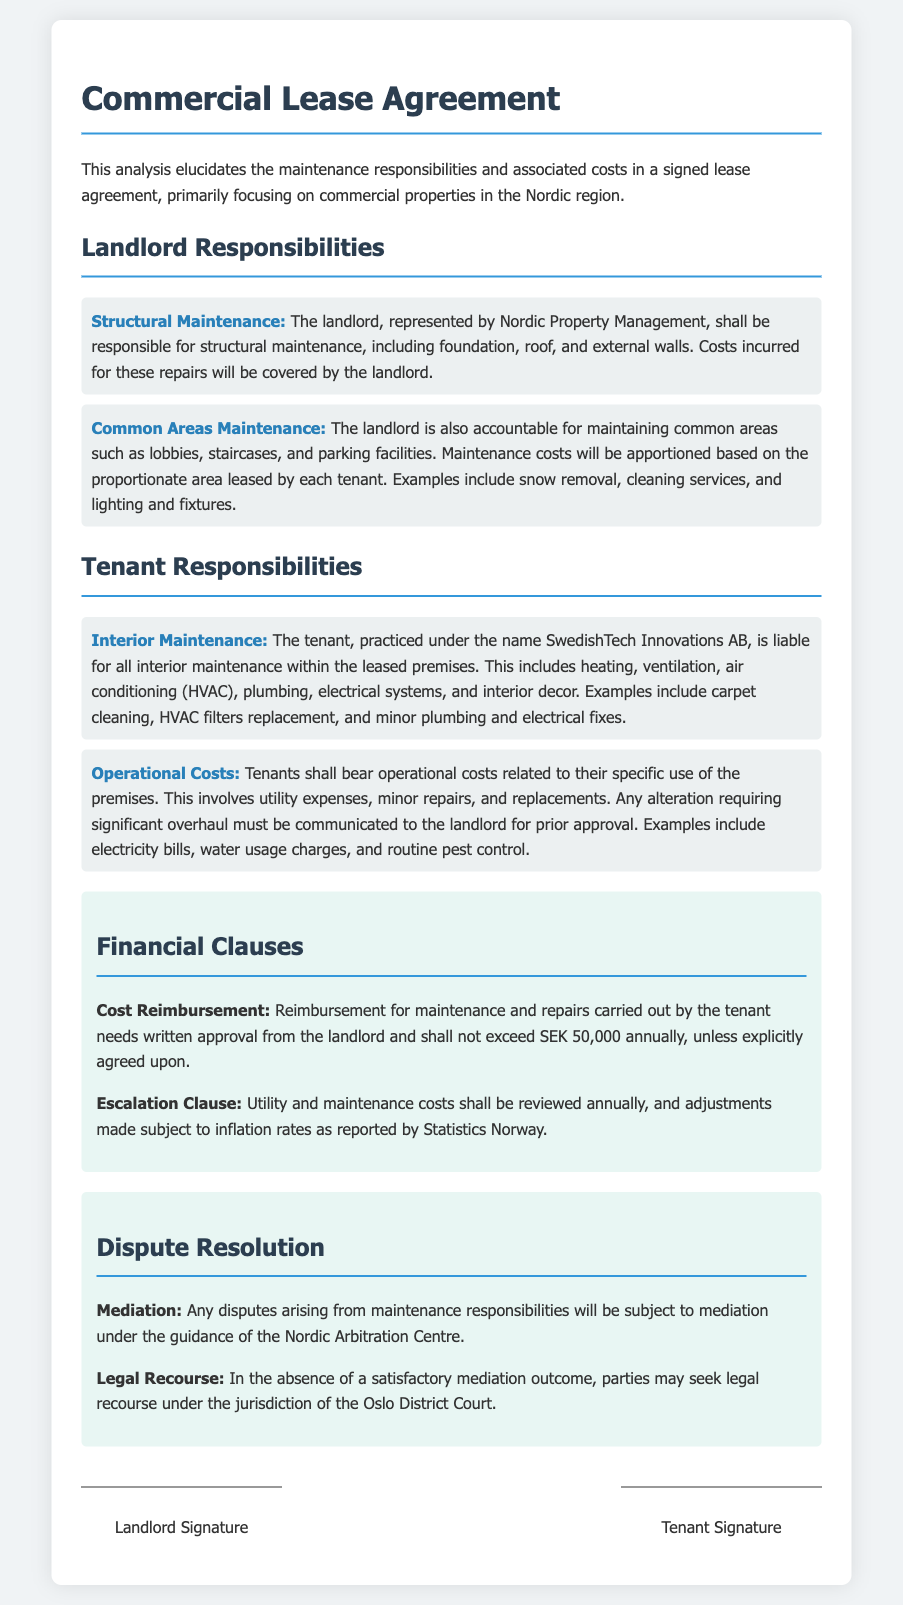what are the landlord's responsibilities? The landlord's responsibilities include structural maintenance and common areas maintenance.
Answer: structural maintenance, common areas maintenance who is the tenant in this lease agreement? The tenant in the lease agreement is identified as SwedishTech Innovations AB.
Answer: SwedishTech Innovations AB what is the annual reimbursement limit for tenant maintenance costs? The document specifies that reimbursement for maintenance does not exceed yearly SEK 50,000 without explicit agreement.
Answer: SEK 50,000 how often are utility and maintenance costs reviewed? According to the financial clauses, utility and maintenance costs are reviewed annually.
Answer: annually what type of mediation is required for disputes? The document mentions that disputes will be subject to mediation under the guidance of the Nordic Arbitration Centre.
Answer: Nordic Arbitration Centre who covers the costs of interior maintenance? The document clearly states that the tenant is liable for all interior maintenance costs.
Answer: tenant what must tenants do for significant alterations? Tenants must communicate any significant alterations requiring overhaul to the landlord for prior approval.
Answer: communicate to the landlord what is the jurisdiction for legal recourse? In case of unsatisfactory mediation, legal recourse can be sought under the jurisdiction of the Oslo District Court.
Answer: Oslo District Court 